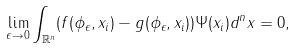Convert formula to latex. <formula><loc_0><loc_0><loc_500><loc_500>\lim _ { \epsilon \to 0 } \int _ { \mathbb { R } ^ { n } } ( f ( \phi _ { \epsilon } , x _ { i } ) - g ( \phi _ { \epsilon } , x _ { i } ) ) \Psi ( x _ { i } ) d ^ { n } x = 0 ,</formula> 